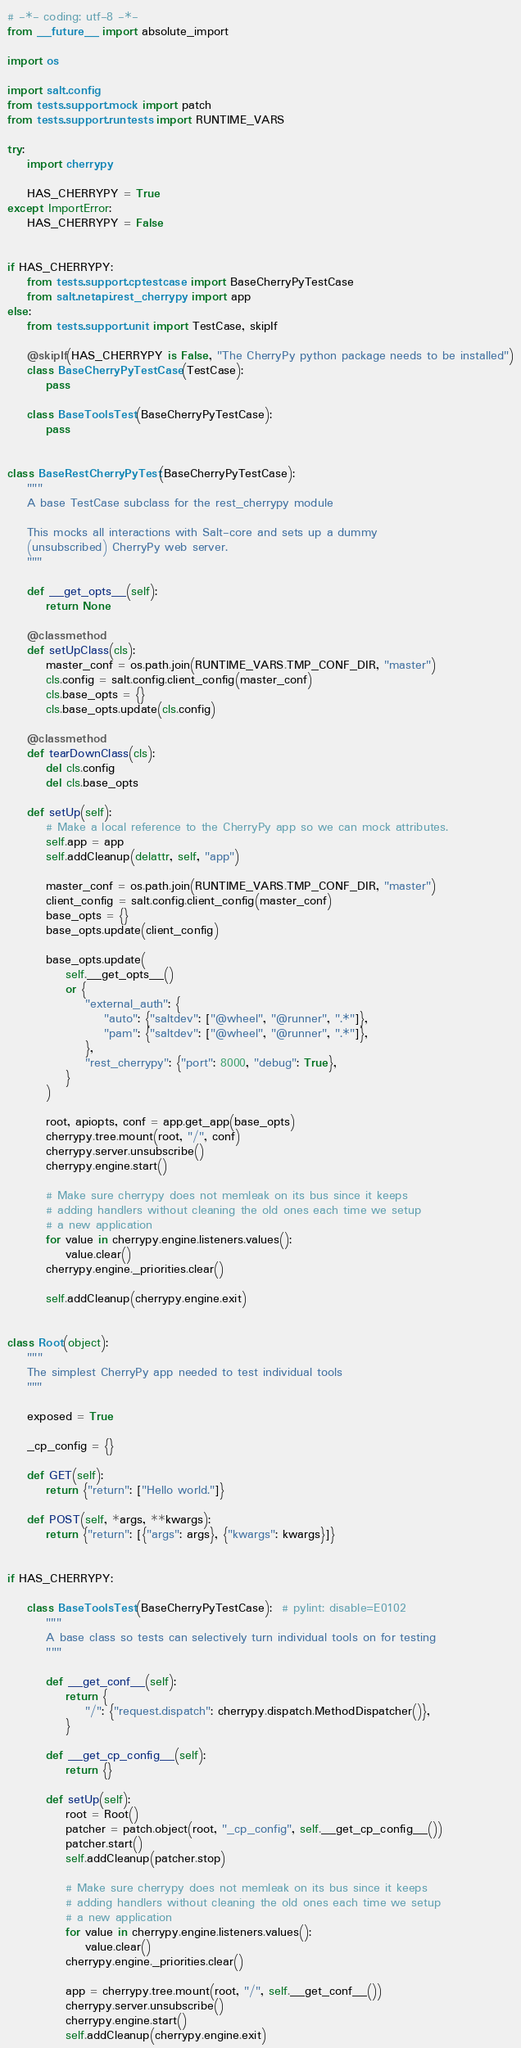Convert code to text. <code><loc_0><loc_0><loc_500><loc_500><_Python_># -*- coding: utf-8 -*-
from __future__ import absolute_import

import os

import salt.config
from tests.support.mock import patch
from tests.support.runtests import RUNTIME_VARS

try:
    import cherrypy

    HAS_CHERRYPY = True
except ImportError:
    HAS_CHERRYPY = False


if HAS_CHERRYPY:
    from tests.support.cptestcase import BaseCherryPyTestCase
    from salt.netapi.rest_cherrypy import app
else:
    from tests.support.unit import TestCase, skipIf

    @skipIf(HAS_CHERRYPY is False, "The CherryPy python package needs to be installed")
    class BaseCherryPyTestCase(TestCase):
        pass

    class BaseToolsTest(BaseCherryPyTestCase):
        pass


class BaseRestCherryPyTest(BaseCherryPyTestCase):
    """
    A base TestCase subclass for the rest_cherrypy module

    This mocks all interactions with Salt-core and sets up a dummy
    (unsubscribed) CherryPy web server.
    """

    def __get_opts__(self):
        return None

    @classmethod
    def setUpClass(cls):
        master_conf = os.path.join(RUNTIME_VARS.TMP_CONF_DIR, "master")
        cls.config = salt.config.client_config(master_conf)
        cls.base_opts = {}
        cls.base_opts.update(cls.config)

    @classmethod
    def tearDownClass(cls):
        del cls.config
        del cls.base_opts

    def setUp(self):
        # Make a local reference to the CherryPy app so we can mock attributes.
        self.app = app
        self.addCleanup(delattr, self, "app")

        master_conf = os.path.join(RUNTIME_VARS.TMP_CONF_DIR, "master")
        client_config = salt.config.client_config(master_conf)
        base_opts = {}
        base_opts.update(client_config)

        base_opts.update(
            self.__get_opts__()
            or {
                "external_auth": {
                    "auto": {"saltdev": ["@wheel", "@runner", ".*"]},
                    "pam": {"saltdev": ["@wheel", "@runner", ".*"]},
                },
                "rest_cherrypy": {"port": 8000, "debug": True},
            }
        )

        root, apiopts, conf = app.get_app(base_opts)
        cherrypy.tree.mount(root, "/", conf)
        cherrypy.server.unsubscribe()
        cherrypy.engine.start()

        # Make sure cherrypy does not memleak on its bus since it keeps
        # adding handlers without cleaning the old ones each time we setup
        # a new application
        for value in cherrypy.engine.listeners.values():
            value.clear()
        cherrypy.engine._priorities.clear()

        self.addCleanup(cherrypy.engine.exit)


class Root(object):
    """
    The simplest CherryPy app needed to test individual tools
    """

    exposed = True

    _cp_config = {}

    def GET(self):
        return {"return": ["Hello world."]}

    def POST(self, *args, **kwargs):
        return {"return": [{"args": args}, {"kwargs": kwargs}]}


if HAS_CHERRYPY:

    class BaseToolsTest(BaseCherryPyTestCase):  # pylint: disable=E0102
        """
        A base class so tests can selectively turn individual tools on for testing
        """

        def __get_conf__(self):
            return {
                "/": {"request.dispatch": cherrypy.dispatch.MethodDispatcher()},
            }

        def __get_cp_config__(self):
            return {}

        def setUp(self):
            root = Root()
            patcher = patch.object(root, "_cp_config", self.__get_cp_config__())
            patcher.start()
            self.addCleanup(patcher.stop)

            # Make sure cherrypy does not memleak on its bus since it keeps
            # adding handlers without cleaning the old ones each time we setup
            # a new application
            for value in cherrypy.engine.listeners.values():
                value.clear()
            cherrypy.engine._priorities.clear()

            app = cherrypy.tree.mount(root, "/", self.__get_conf__())
            cherrypy.server.unsubscribe()
            cherrypy.engine.start()
            self.addCleanup(cherrypy.engine.exit)
</code> 